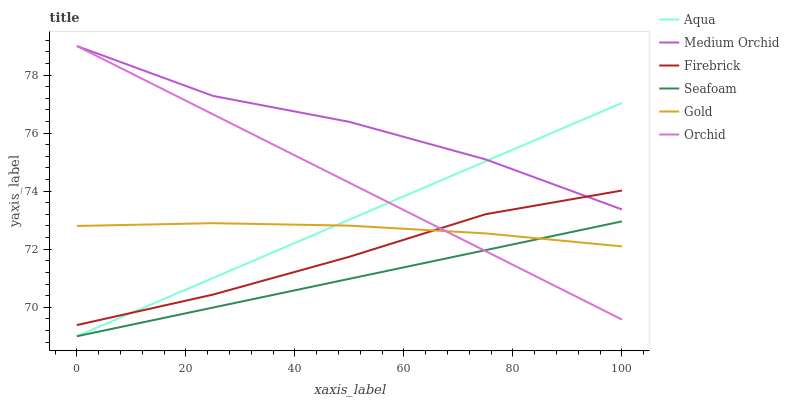Does Seafoam have the minimum area under the curve?
Answer yes or no. Yes. Does Medium Orchid have the maximum area under the curve?
Answer yes or no. Yes. Does Firebrick have the minimum area under the curve?
Answer yes or no. No. Does Firebrick have the maximum area under the curve?
Answer yes or no. No. Is Seafoam the smoothest?
Answer yes or no. Yes. Is Medium Orchid the roughest?
Answer yes or no. Yes. Is Firebrick the smoothest?
Answer yes or no. No. Is Firebrick the roughest?
Answer yes or no. No. Does Aqua have the lowest value?
Answer yes or no. Yes. Does Firebrick have the lowest value?
Answer yes or no. No. Does Orchid have the highest value?
Answer yes or no. Yes. Does Firebrick have the highest value?
Answer yes or no. No. Is Seafoam less than Firebrick?
Answer yes or no. Yes. Is Medium Orchid greater than Seafoam?
Answer yes or no. Yes. Does Medium Orchid intersect Aqua?
Answer yes or no. Yes. Is Medium Orchid less than Aqua?
Answer yes or no. No. Is Medium Orchid greater than Aqua?
Answer yes or no. No. Does Seafoam intersect Firebrick?
Answer yes or no. No. 